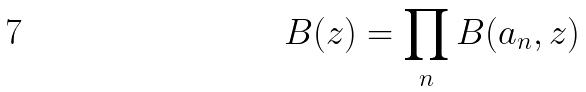Convert formula to latex. <formula><loc_0><loc_0><loc_500><loc_500>B ( z ) = \prod _ { n } B ( a _ { n } , z )</formula> 